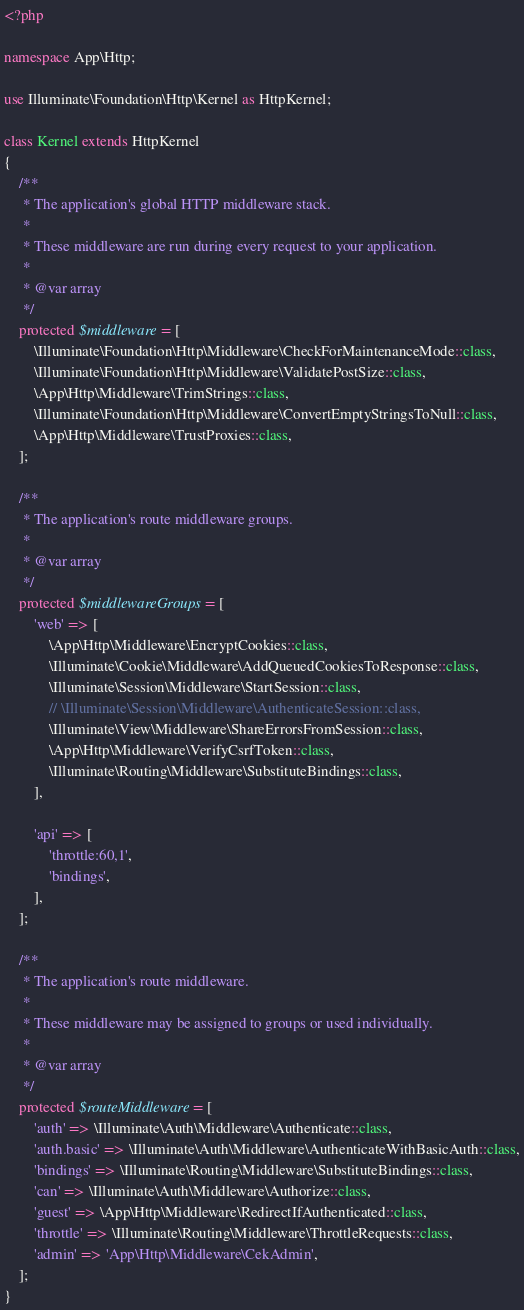<code> <loc_0><loc_0><loc_500><loc_500><_PHP_><?php

namespace App\Http;

use Illuminate\Foundation\Http\Kernel as HttpKernel;

class Kernel extends HttpKernel
{
    /**
     * The application's global HTTP middleware stack.
     *
     * These middleware are run during every request to your application.
     *
     * @var array
     */
    protected $middleware = [
        \Illuminate\Foundation\Http\Middleware\CheckForMaintenanceMode::class,
        \Illuminate\Foundation\Http\Middleware\ValidatePostSize::class,
        \App\Http\Middleware\TrimStrings::class,
        \Illuminate\Foundation\Http\Middleware\ConvertEmptyStringsToNull::class,
        \App\Http\Middleware\TrustProxies::class,
    ];

    /**
     * The application's route middleware groups.
     *
     * @var array
     */
    protected $middlewareGroups = [
        'web' => [
            \App\Http\Middleware\EncryptCookies::class,
            \Illuminate\Cookie\Middleware\AddQueuedCookiesToResponse::class,
            \Illuminate\Session\Middleware\StartSession::class,
            // \Illuminate\Session\Middleware\AuthenticateSession::class,
            \Illuminate\View\Middleware\ShareErrorsFromSession::class,
            \App\Http\Middleware\VerifyCsrfToken::class,
            \Illuminate\Routing\Middleware\SubstituteBindings::class,
        ],

        'api' => [
            'throttle:60,1',
            'bindings',
        ],
    ];

    /**
     * The application's route middleware.
     *
     * These middleware may be assigned to groups or used individually.
     *
     * @var array
     */
    protected $routeMiddleware = [
        'auth' => \Illuminate\Auth\Middleware\Authenticate::class,
        'auth.basic' => \Illuminate\Auth\Middleware\AuthenticateWithBasicAuth::class,
        'bindings' => \Illuminate\Routing\Middleware\SubstituteBindings::class,
        'can' => \Illuminate\Auth\Middleware\Authorize::class,
        'guest' => \App\Http\Middleware\RedirectIfAuthenticated::class,
        'throttle' => \Illuminate\Routing\Middleware\ThrottleRequests::class,
        'admin' => 'App\Http\Middleware\CekAdmin',
    ];
}
</code> 